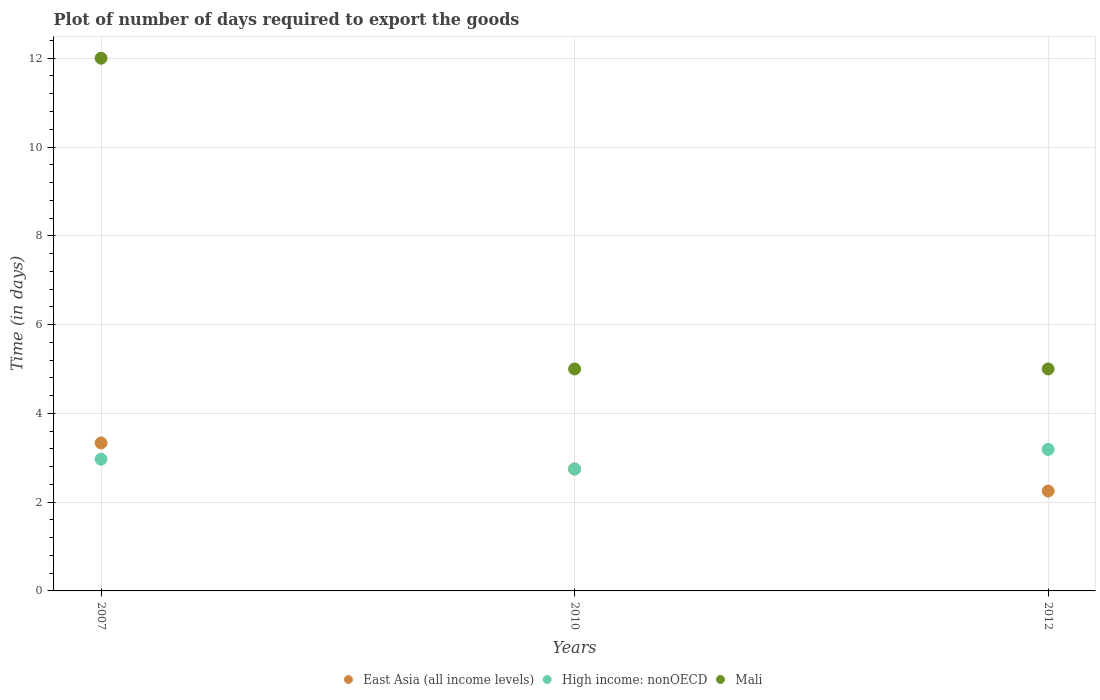How many different coloured dotlines are there?
Provide a succinct answer. 3. Across all years, what is the minimum time required to export goods in East Asia (all income levels)?
Your answer should be very brief. 2.25. In which year was the time required to export goods in High income: nonOECD maximum?
Make the answer very short. 2012. What is the total time required to export goods in East Asia (all income levels) in the graph?
Make the answer very short. 8.33. What is the difference between the time required to export goods in Mali in 2007 and the time required to export goods in High income: nonOECD in 2012?
Give a very brief answer. 8.81. What is the average time required to export goods in High income: nonOECD per year?
Offer a terse response. 2.97. In the year 2012, what is the difference between the time required to export goods in East Asia (all income levels) and time required to export goods in High income: nonOECD?
Offer a very short reply. -0.94. Is the time required to export goods in High income: nonOECD in 2007 less than that in 2010?
Your answer should be very brief. No. What is the difference between the highest and the lowest time required to export goods in East Asia (all income levels)?
Keep it short and to the point. 1.08. Is the sum of the time required to export goods in East Asia (all income levels) in 2010 and 2012 greater than the maximum time required to export goods in Mali across all years?
Offer a terse response. No. Does the time required to export goods in Mali monotonically increase over the years?
Ensure brevity in your answer.  No. How many dotlines are there?
Provide a succinct answer. 3. How many years are there in the graph?
Give a very brief answer. 3. What is the difference between two consecutive major ticks on the Y-axis?
Give a very brief answer. 2. Are the values on the major ticks of Y-axis written in scientific E-notation?
Offer a very short reply. No. Does the graph contain any zero values?
Ensure brevity in your answer.  No. Where does the legend appear in the graph?
Make the answer very short. Bottom center. How many legend labels are there?
Offer a very short reply. 3. How are the legend labels stacked?
Ensure brevity in your answer.  Horizontal. What is the title of the graph?
Your answer should be compact. Plot of number of days required to export the goods. What is the label or title of the X-axis?
Provide a succinct answer. Years. What is the label or title of the Y-axis?
Keep it short and to the point. Time (in days). What is the Time (in days) of East Asia (all income levels) in 2007?
Make the answer very short. 3.33. What is the Time (in days) of High income: nonOECD in 2007?
Offer a terse response. 2.97. What is the Time (in days) in East Asia (all income levels) in 2010?
Your answer should be very brief. 2.75. What is the Time (in days) in High income: nonOECD in 2010?
Offer a terse response. 2.75. What is the Time (in days) in Mali in 2010?
Provide a succinct answer. 5. What is the Time (in days) in East Asia (all income levels) in 2012?
Keep it short and to the point. 2.25. What is the Time (in days) of High income: nonOECD in 2012?
Offer a terse response. 3.19. What is the Time (in days) of Mali in 2012?
Offer a very short reply. 5. Across all years, what is the maximum Time (in days) in East Asia (all income levels)?
Make the answer very short. 3.33. Across all years, what is the maximum Time (in days) of High income: nonOECD?
Your answer should be compact. 3.19. Across all years, what is the maximum Time (in days) in Mali?
Provide a succinct answer. 12. Across all years, what is the minimum Time (in days) of East Asia (all income levels)?
Keep it short and to the point. 2.25. Across all years, what is the minimum Time (in days) in High income: nonOECD?
Offer a very short reply. 2.75. Across all years, what is the minimum Time (in days) of Mali?
Ensure brevity in your answer.  5. What is the total Time (in days) of East Asia (all income levels) in the graph?
Provide a succinct answer. 8.33. What is the total Time (in days) in High income: nonOECD in the graph?
Give a very brief answer. 8.9. What is the total Time (in days) in Mali in the graph?
Provide a short and direct response. 22. What is the difference between the Time (in days) of East Asia (all income levels) in 2007 and that in 2010?
Your answer should be very brief. 0.59. What is the difference between the Time (in days) of High income: nonOECD in 2007 and that in 2010?
Your answer should be very brief. 0.22. What is the difference between the Time (in days) of Mali in 2007 and that in 2010?
Provide a succinct answer. 7. What is the difference between the Time (in days) in East Asia (all income levels) in 2007 and that in 2012?
Your response must be concise. 1.08. What is the difference between the Time (in days) of High income: nonOECD in 2007 and that in 2012?
Give a very brief answer. -0.22. What is the difference between the Time (in days) of East Asia (all income levels) in 2010 and that in 2012?
Provide a short and direct response. 0.5. What is the difference between the Time (in days) of High income: nonOECD in 2010 and that in 2012?
Offer a very short reply. -0.44. What is the difference between the Time (in days) in East Asia (all income levels) in 2007 and the Time (in days) in High income: nonOECD in 2010?
Offer a very short reply. 0.59. What is the difference between the Time (in days) of East Asia (all income levels) in 2007 and the Time (in days) of Mali in 2010?
Give a very brief answer. -1.67. What is the difference between the Time (in days) in High income: nonOECD in 2007 and the Time (in days) in Mali in 2010?
Provide a succinct answer. -2.03. What is the difference between the Time (in days) in East Asia (all income levels) in 2007 and the Time (in days) in High income: nonOECD in 2012?
Your response must be concise. 0.15. What is the difference between the Time (in days) in East Asia (all income levels) in 2007 and the Time (in days) in Mali in 2012?
Your response must be concise. -1.67. What is the difference between the Time (in days) in High income: nonOECD in 2007 and the Time (in days) in Mali in 2012?
Ensure brevity in your answer.  -2.03. What is the difference between the Time (in days) in East Asia (all income levels) in 2010 and the Time (in days) in High income: nonOECD in 2012?
Keep it short and to the point. -0.44. What is the difference between the Time (in days) in East Asia (all income levels) in 2010 and the Time (in days) in Mali in 2012?
Give a very brief answer. -2.25. What is the difference between the Time (in days) in High income: nonOECD in 2010 and the Time (in days) in Mali in 2012?
Offer a terse response. -2.25. What is the average Time (in days) in East Asia (all income levels) per year?
Offer a very short reply. 2.78. What is the average Time (in days) in High income: nonOECD per year?
Your answer should be very brief. 2.97. What is the average Time (in days) in Mali per year?
Your response must be concise. 7.33. In the year 2007, what is the difference between the Time (in days) in East Asia (all income levels) and Time (in days) in High income: nonOECD?
Your response must be concise. 0.37. In the year 2007, what is the difference between the Time (in days) in East Asia (all income levels) and Time (in days) in Mali?
Provide a short and direct response. -8.67. In the year 2007, what is the difference between the Time (in days) of High income: nonOECD and Time (in days) of Mali?
Give a very brief answer. -9.03. In the year 2010, what is the difference between the Time (in days) in East Asia (all income levels) and Time (in days) in Mali?
Provide a succinct answer. -2.25. In the year 2010, what is the difference between the Time (in days) of High income: nonOECD and Time (in days) of Mali?
Give a very brief answer. -2.25. In the year 2012, what is the difference between the Time (in days) in East Asia (all income levels) and Time (in days) in High income: nonOECD?
Provide a short and direct response. -0.94. In the year 2012, what is the difference between the Time (in days) of East Asia (all income levels) and Time (in days) of Mali?
Your answer should be very brief. -2.75. In the year 2012, what is the difference between the Time (in days) of High income: nonOECD and Time (in days) of Mali?
Offer a very short reply. -1.81. What is the ratio of the Time (in days) of East Asia (all income levels) in 2007 to that in 2010?
Keep it short and to the point. 1.21. What is the ratio of the Time (in days) in High income: nonOECD in 2007 to that in 2010?
Provide a succinct answer. 1.08. What is the ratio of the Time (in days) in Mali in 2007 to that in 2010?
Your answer should be very brief. 2.4. What is the ratio of the Time (in days) in East Asia (all income levels) in 2007 to that in 2012?
Your answer should be very brief. 1.48. What is the ratio of the Time (in days) of High income: nonOECD in 2007 to that in 2012?
Offer a very short reply. 0.93. What is the ratio of the Time (in days) in East Asia (all income levels) in 2010 to that in 2012?
Your response must be concise. 1.22. What is the ratio of the Time (in days) of High income: nonOECD in 2010 to that in 2012?
Give a very brief answer. 0.86. What is the ratio of the Time (in days) of Mali in 2010 to that in 2012?
Keep it short and to the point. 1. What is the difference between the highest and the second highest Time (in days) of East Asia (all income levels)?
Keep it short and to the point. 0.59. What is the difference between the highest and the second highest Time (in days) of High income: nonOECD?
Your answer should be compact. 0.22. What is the difference between the highest and the second highest Time (in days) of Mali?
Provide a short and direct response. 7. What is the difference between the highest and the lowest Time (in days) in East Asia (all income levels)?
Ensure brevity in your answer.  1.08. What is the difference between the highest and the lowest Time (in days) in High income: nonOECD?
Your response must be concise. 0.44. 